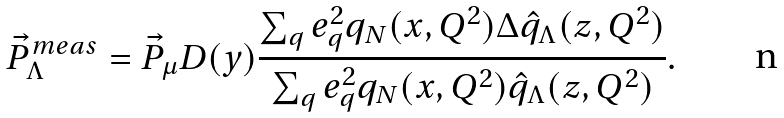<formula> <loc_0><loc_0><loc_500><loc_500>\vec { P } ^ { m e a s } _ { \Lambda } = \vec { P } _ { \mu } D ( y ) \frac { \sum _ { q } e _ { q } ^ { 2 } q _ { N } ( x , Q ^ { 2 } ) \Delta \hat { q } _ { \Lambda } ( z , Q ^ { 2 } ) } { \sum _ { q } e _ { q } ^ { 2 } q _ { N } ( x , Q ^ { 2 } ) \hat { q } _ { \Lambda } ( z , Q ^ { 2 } ) } .</formula> 